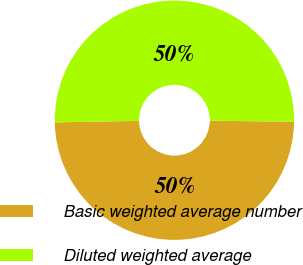<chart> <loc_0><loc_0><loc_500><loc_500><pie_chart><fcel>Basic weighted average number<fcel>Diluted weighted average<nl><fcel>49.51%<fcel>50.49%<nl></chart> 